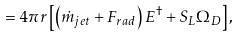<formula> <loc_0><loc_0><loc_500><loc_500>\quad = 4 \pi r \left [ { \left ( { \dot { m } _ { j e t } + F _ { r a d } } \right ) E ^ { \dag } + S _ { L } \Omega _ { D } } \right ] ,</formula> 